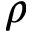Convert formula to latex. <formula><loc_0><loc_0><loc_500><loc_500>\rho</formula> 